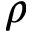Convert formula to latex. <formula><loc_0><loc_0><loc_500><loc_500>\rho</formula> 